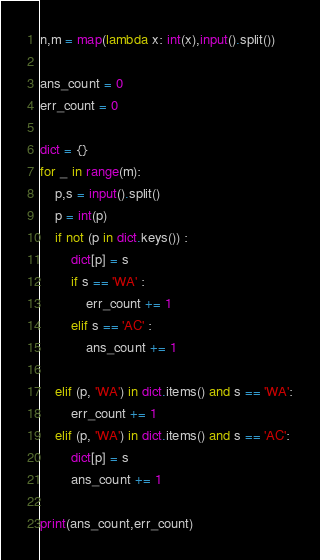<code> <loc_0><loc_0><loc_500><loc_500><_Python_>n,m = map(lambda x: int(x),input().split())

ans_count = 0
err_count = 0

dict = {}
for _ in range(m):
    p,s = input().split()
    p = int(p)
    if not (p in dict.keys()) :
        dict[p] = s
        if s == 'WA' :
            err_count += 1
        elif s == 'AC' :
            ans_count += 1

    elif (p, 'WA') in dict.items() and s == 'WA':
        err_count += 1
    elif (p, 'WA') in dict.items() and s == 'AC':
        dict[p] = s
        ans_count += 1

print(ans_count,err_count)
</code> 